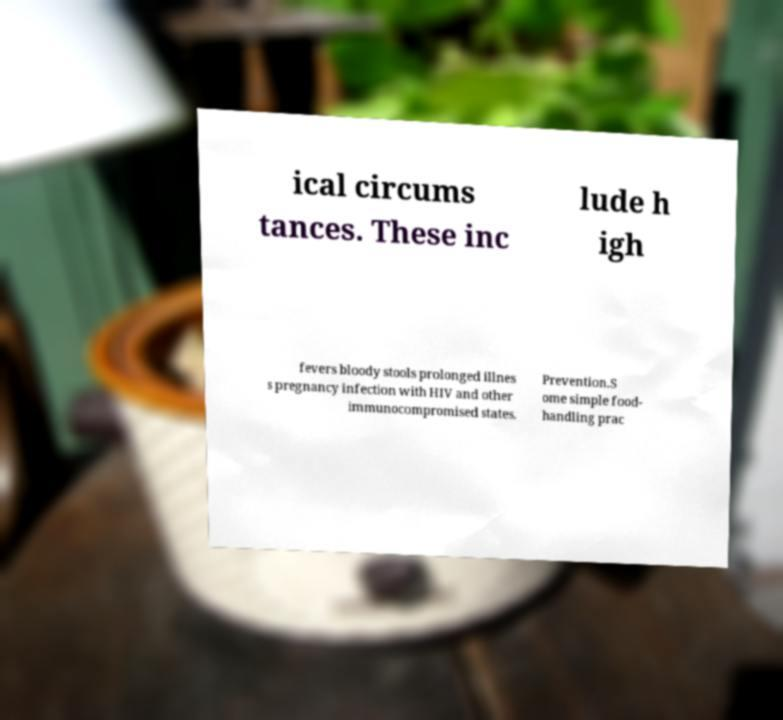Could you extract and type out the text from this image? ical circums tances. These inc lude h igh fevers bloody stools prolonged illnes s pregnancy infection with HIV and other immunocompromised states. Prevention.S ome simple food- handling prac 